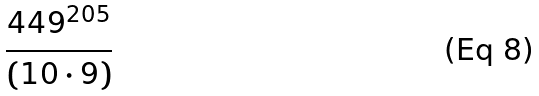Convert formula to latex. <formula><loc_0><loc_0><loc_500><loc_500>\frac { 4 4 9 ^ { 2 0 5 } } { ( 1 0 \cdot 9 ) }</formula> 